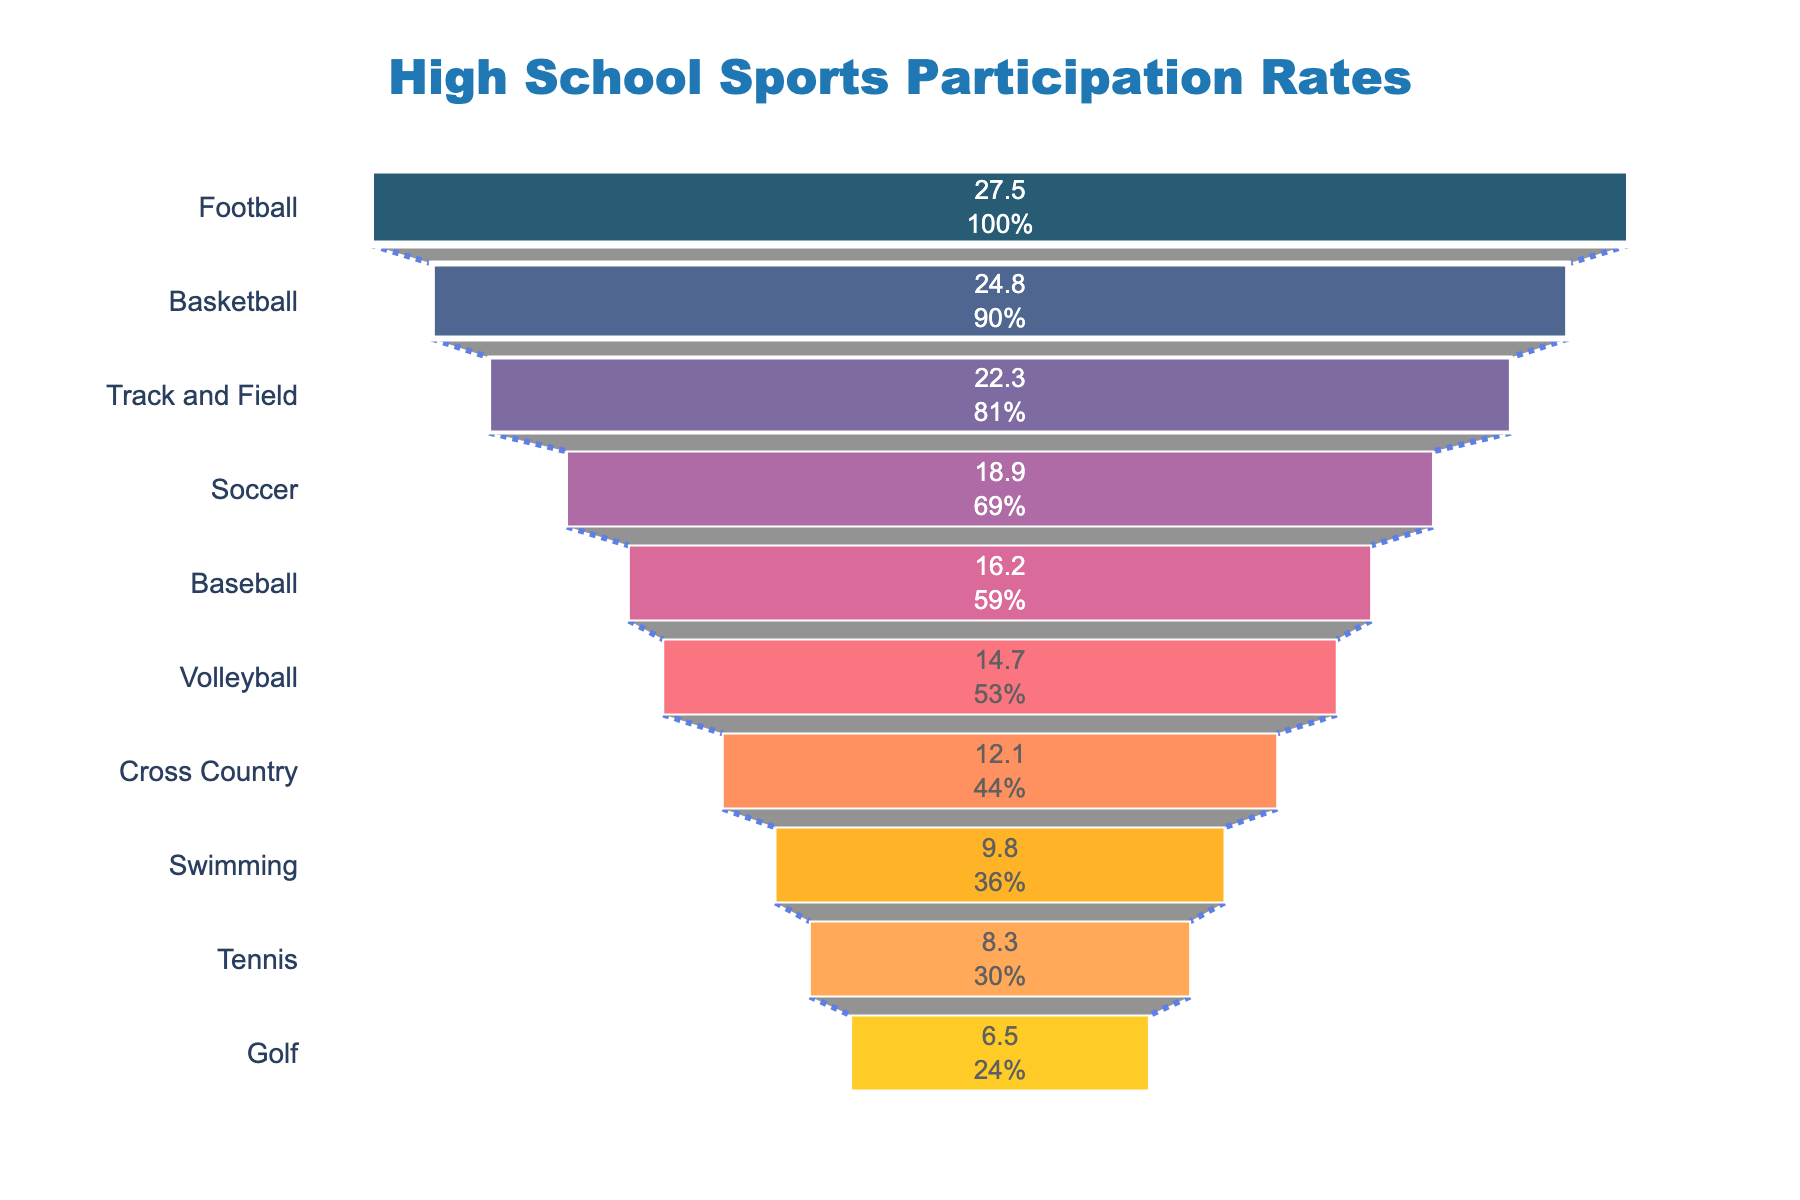What is the title of the funnel chart? The title of the chart is usually placed at the top of the figure to provide a quick understanding of what the chart represents. By viewing the top section of the chart, we can easily identify the title.
Answer: High School Sports Participation Rates Which sport has the highest participation rate? The funnel chart is arranged from top to bottom, with the widest part representing the highest value. The first sport listed at the top with the widest section indicates the highest participation rate.
Answer: Football How many sports are represented in the funnel chart? The funnel chart shows each sport in a funnel layer. By counting the number of segments, each representing a different sport, we can determine the total number of sports displayed.
Answer: 10 What is the difference in participation rates between Football and Soccer? We first identify the participation rates for both Football and Soccer from the chart. Football has a participation rate of 27.5, and Soccer has a rate of 18.9. Subtracting the two gives the difference.
Answer: 8.6 Which sport has a lower participation rate, Tennis or Swimming? By comparing the respective sections in the funnel chart, we observe the positions of Tennis and Swimming. The sport that is placed lower in the chart has a lower participation rate.
Answer: Tennis What is the combined participation rate of Volleyball, Cross Country, and Swimming? We find the participation rates for Volleyball (14.7), Cross Country (12.1), and Swimming (9.8) and then add them together to get the combined participation rate.
Answer: 36.6 What sport is immediately less popular than Track and Field according to the chart? The sport immediately below a particular sport in a funnel chart has a lower participation rate. By locating Track and Field and moving one step down, we find the next sport.
Answer: Soccer What is the average participation rate of the top three sports? We identify the top three sports as Football (27.5), Basketball (24.8), and Track and Field (22.3). We sum these values and then divide by the number of sports (3) to get the average rate.
Answer: 24.87 Which sport has nearly half the participation rate of Football? We look for the sport whose participation rate is approximately half of Football’s rate (27.5/2 = 13.75). Comparing the rates, we find that Volleyball (14.7) is closest to this half value.
Answer: Volleyball 